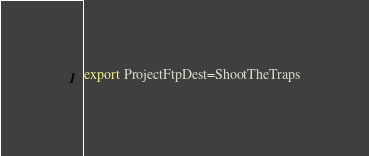Convert code to text. <code><loc_0><loc_0><loc_500><loc_500><_Bash_>export ProjectFtpDest=ShootTheTraps

</code> 